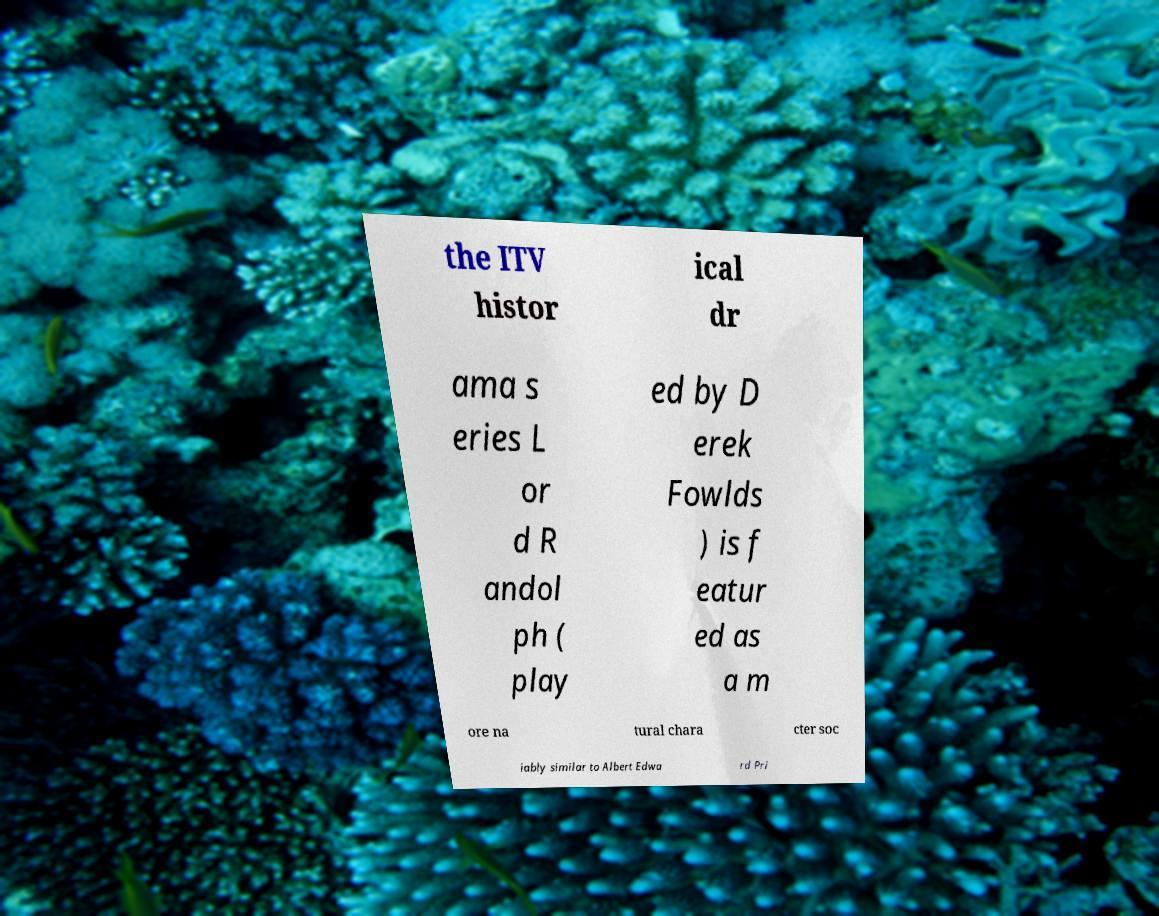Can you read and provide the text displayed in the image?This photo seems to have some interesting text. Can you extract and type it out for me? the ITV histor ical dr ama s eries L or d R andol ph ( play ed by D erek Fowlds ) is f eatur ed as a m ore na tural chara cter soc iably similar to Albert Edwa rd Pri 